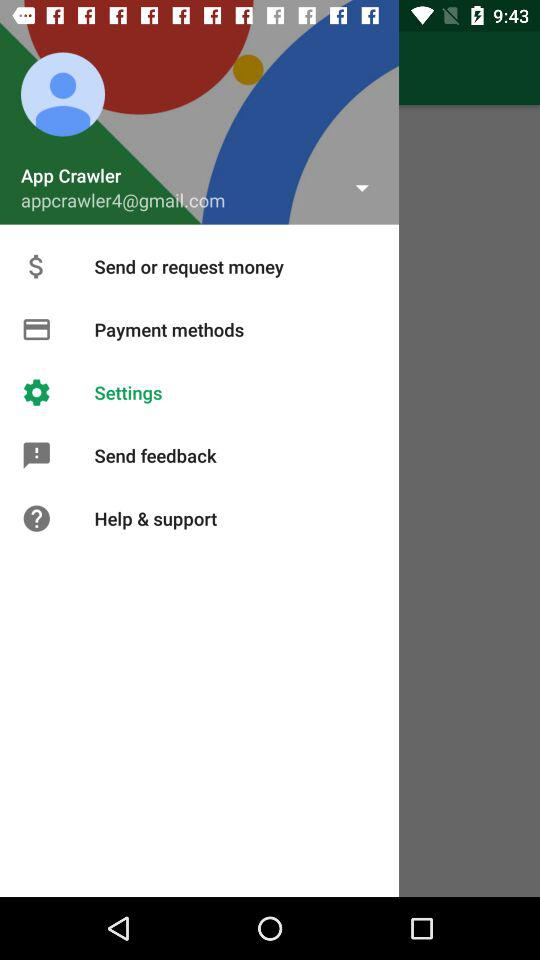What's the name of the person? The person name is "App Crawler". 